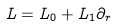<formula> <loc_0><loc_0><loc_500><loc_500>L = L _ { 0 } + L _ { 1 } \partial _ { r }</formula> 